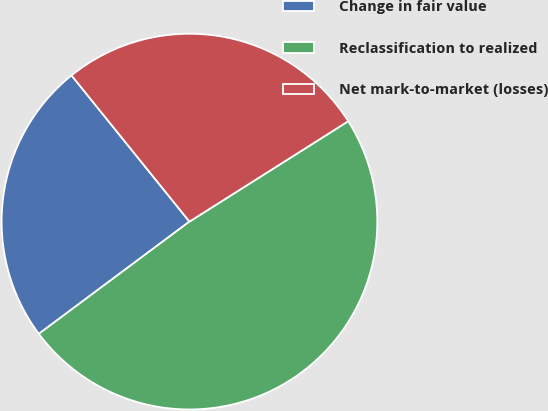Convert chart. <chart><loc_0><loc_0><loc_500><loc_500><pie_chart><fcel>Change in fair value<fcel>Reclassification to realized<fcel>Net mark-to-market (losses)<nl><fcel>24.39%<fcel>48.78%<fcel>26.83%<nl></chart> 